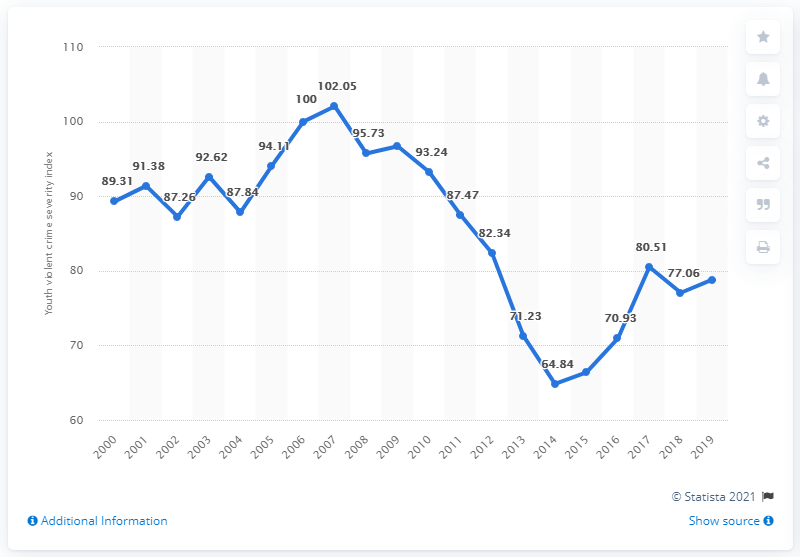Mention a couple of crucial points in this snapshot. In the year 2000, the youth violent crime severity index was 89.31. In 2019, the youth violent crime severity index in Canada was 78.82. 